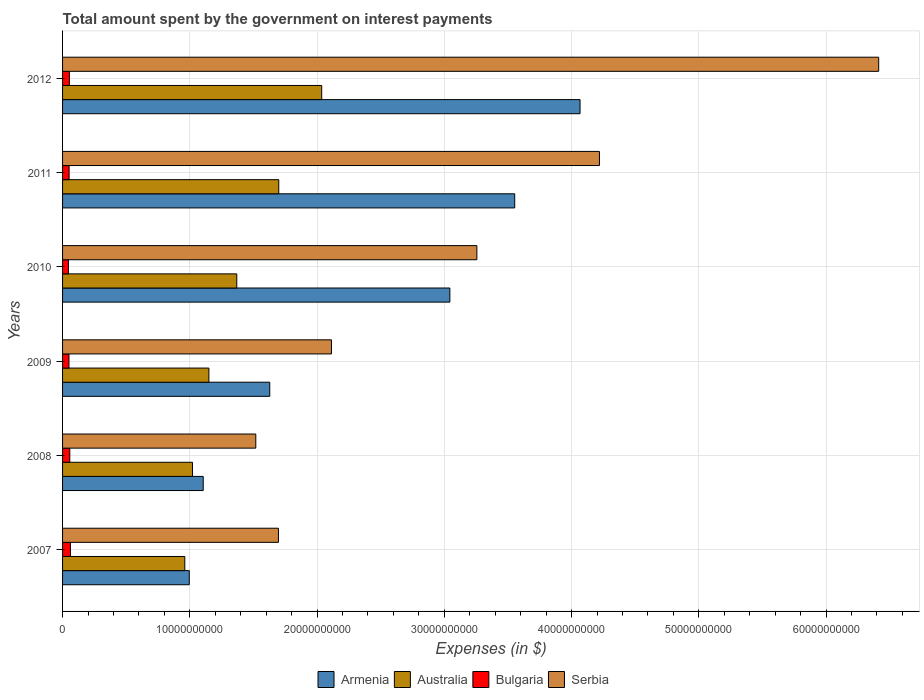How many groups of bars are there?
Keep it short and to the point. 6. Are the number of bars on each tick of the Y-axis equal?
Make the answer very short. Yes. How many bars are there on the 4th tick from the top?
Offer a very short reply. 4. How many bars are there on the 1st tick from the bottom?
Provide a short and direct response. 4. What is the label of the 6th group of bars from the top?
Give a very brief answer. 2007. In how many cases, is the number of bars for a given year not equal to the number of legend labels?
Ensure brevity in your answer.  0. What is the amount spent on interest payments by the government in Australia in 2012?
Make the answer very short. 2.04e+1. Across all years, what is the maximum amount spent on interest payments by the government in Australia?
Your response must be concise. 2.04e+1. Across all years, what is the minimum amount spent on interest payments by the government in Australia?
Ensure brevity in your answer.  9.60e+09. In which year was the amount spent on interest payments by the government in Bulgaria minimum?
Provide a short and direct response. 2010. What is the total amount spent on interest payments by the government in Serbia in the graph?
Make the answer very short. 1.92e+11. What is the difference between the amount spent on interest payments by the government in Armenia in 2007 and that in 2008?
Give a very brief answer. -1.10e+09. What is the difference between the amount spent on interest payments by the government in Bulgaria in 2011 and the amount spent on interest payments by the government in Serbia in 2008?
Keep it short and to the point. -1.47e+1. What is the average amount spent on interest payments by the government in Bulgaria per year?
Your answer should be compact. 5.33e+08. In the year 2009, what is the difference between the amount spent on interest payments by the government in Bulgaria and amount spent on interest payments by the government in Serbia?
Give a very brief answer. -2.06e+1. In how many years, is the amount spent on interest payments by the government in Armenia greater than 40000000000 $?
Your response must be concise. 1. What is the ratio of the amount spent on interest payments by the government in Bulgaria in 2007 to that in 2008?
Your response must be concise. 1.09. What is the difference between the highest and the second highest amount spent on interest payments by the government in Bulgaria?
Offer a terse response. 5.00e+07. What is the difference between the highest and the lowest amount spent on interest payments by the government in Bulgaria?
Provide a succinct answer. 1.59e+08. Is it the case that in every year, the sum of the amount spent on interest payments by the government in Serbia and amount spent on interest payments by the government in Australia is greater than the sum of amount spent on interest payments by the government in Bulgaria and amount spent on interest payments by the government in Armenia?
Give a very brief answer. No. What does the 1st bar from the bottom in 2010 represents?
Make the answer very short. Armenia. How many years are there in the graph?
Offer a very short reply. 6. Are the values on the major ticks of X-axis written in scientific E-notation?
Your answer should be very brief. No. Does the graph contain any zero values?
Provide a short and direct response. No. Where does the legend appear in the graph?
Give a very brief answer. Bottom center. What is the title of the graph?
Make the answer very short. Total amount spent by the government on interest payments. Does "Bangladesh" appear as one of the legend labels in the graph?
Provide a short and direct response. No. What is the label or title of the X-axis?
Your response must be concise. Expenses (in $). What is the label or title of the Y-axis?
Your answer should be compact. Years. What is the Expenses (in $) in Armenia in 2007?
Keep it short and to the point. 9.96e+09. What is the Expenses (in $) in Australia in 2007?
Your answer should be compact. 9.60e+09. What is the Expenses (in $) of Bulgaria in 2007?
Ensure brevity in your answer.  6.19e+08. What is the Expenses (in $) of Serbia in 2007?
Provide a succinct answer. 1.70e+1. What is the Expenses (in $) in Armenia in 2008?
Provide a short and direct response. 1.11e+1. What is the Expenses (in $) in Australia in 2008?
Your answer should be very brief. 1.02e+1. What is the Expenses (in $) of Bulgaria in 2008?
Offer a very short reply. 5.69e+08. What is the Expenses (in $) in Serbia in 2008?
Your response must be concise. 1.52e+1. What is the Expenses (in $) of Armenia in 2009?
Provide a short and direct response. 1.63e+1. What is the Expenses (in $) in Australia in 2009?
Provide a short and direct response. 1.15e+1. What is the Expenses (in $) in Bulgaria in 2009?
Provide a succinct answer. 5.03e+08. What is the Expenses (in $) of Serbia in 2009?
Your answer should be very brief. 2.11e+1. What is the Expenses (in $) of Armenia in 2010?
Provide a succinct answer. 3.04e+1. What is the Expenses (in $) of Australia in 2010?
Keep it short and to the point. 1.37e+1. What is the Expenses (in $) in Bulgaria in 2010?
Make the answer very short. 4.60e+08. What is the Expenses (in $) of Serbia in 2010?
Provide a short and direct response. 3.26e+1. What is the Expenses (in $) of Armenia in 2011?
Offer a terse response. 3.55e+1. What is the Expenses (in $) of Australia in 2011?
Your response must be concise. 1.70e+1. What is the Expenses (in $) of Bulgaria in 2011?
Offer a very short reply. 5.15e+08. What is the Expenses (in $) in Serbia in 2011?
Your answer should be compact. 4.22e+1. What is the Expenses (in $) in Armenia in 2012?
Offer a very short reply. 4.07e+1. What is the Expenses (in $) of Australia in 2012?
Give a very brief answer. 2.04e+1. What is the Expenses (in $) of Bulgaria in 2012?
Provide a succinct answer. 5.36e+08. What is the Expenses (in $) of Serbia in 2012?
Your answer should be compact. 6.41e+1. Across all years, what is the maximum Expenses (in $) in Armenia?
Provide a short and direct response. 4.07e+1. Across all years, what is the maximum Expenses (in $) of Australia?
Give a very brief answer. 2.04e+1. Across all years, what is the maximum Expenses (in $) of Bulgaria?
Keep it short and to the point. 6.19e+08. Across all years, what is the maximum Expenses (in $) of Serbia?
Keep it short and to the point. 6.41e+1. Across all years, what is the minimum Expenses (in $) in Armenia?
Offer a very short reply. 9.96e+09. Across all years, what is the minimum Expenses (in $) of Australia?
Offer a terse response. 9.60e+09. Across all years, what is the minimum Expenses (in $) of Bulgaria?
Your response must be concise. 4.60e+08. Across all years, what is the minimum Expenses (in $) in Serbia?
Your answer should be compact. 1.52e+1. What is the total Expenses (in $) of Armenia in the graph?
Offer a terse response. 1.44e+11. What is the total Expenses (in $) of Australia in the graph?
Provide a succinct answer. 8.24e+1. What is the total Expenses (in $) of Bulgaria in the graph?
Ensure brevity in your answer.  3.20e+09. What is the total Expenses (in $) of Serbia in the graph?
Provide a succinct answer. 1.92e+11. What is the difference between the Expenses (in $) of Armenia in 2007 and that in 2008?
Make the answer very short. -1.10e+09. What is the difference between the Expenses (in $) of Australia in 2007 and that in 2008?
Provide a succinct answer. -6.05e+08. What is the difference between the Expenses (in $) in Bulgaria in 2007 and that in 2008?
Your answer should be compact. 5.00e+07. What is the difference between the Expenses (in $) in Serbia in 2007 and that in 2008?
Your answer should be compact. 1.78e+09. What is the difference between the Expenses (in $) of Armenia in 2007 and that in 2009?
Make the answer very short. -6.32e+09. What is the difference between the Expenses (in $) of Australia in 2007 and that in 2009?
Offer a terse response. -1.89e+09. What is the difference between the Expenses (in $) in Bulgaria in 2007 and that in 2009?
Your answer should be very brief. 1.16e+08. What is the difference between the Expenses (in $) in Serbia in 2007 and that in 2009?
Make the answer very short. -4.17e+09. What is the difference between the Expenses (in $) of Armenia in 2007 and that in 2010?
Provide a succinct answer. -2.05e+1. What is the difference between the Expenses (in $) of Australia in 2007 and that in 2010?
Your answer should be compact. -4.09e+09. What is the difference between the Expenses (in $) of Bulgaria in 2007 and that in 2010?
Provide a succinct answer. 1.59e+08. What is the difference between the Expenses (in $) of Serbia in 2007 and that in 2010?
Give a very brief answer. -1.56e+1. What is the difference between the Expenses (in $) of Armenia in 2007 and that in 2011?
Offer a terse response. -2.56e+1. What is the difference between the Expenses (in $) of Australia in 2007 and that in 2011?
Give a very brief answer. -7.38e+09. What is the difference between the Expenses (in $) in Bulgaria in 2007 and that in 2011?
Make the answer very short. 1.04e+08. What is the difference between the Expenses (in $) of Serbia in 2007 and that in 2011?
Offer a terse response. -2.52e+1. What is the difference between the Expenses (in $) in Armenia in 2007 and that in 2012?
Your response must be concise. -3.07e+1. What is the difference between the Expenses (in $) in Australia in 2007 and that in 2012?
Offer a very short reply. -1.08e+1. What is the difference between the Expenses (in $) of Bulgaria in 2007 and that in 2012?
Your response must be concise. 8.26e+07. What is the difference between the Expenses (in $) of Serbia in 2007 and that in 2012?
Give a very brief answer. -4.72e+1. What is the difference between the Expenses (in $) of Armenia in 2008 and that in 2009?
Your answer should be very brief. -5.23e+09. What is the difference between the Expenses (in $) of Australia in 2008 and that in 2009?
Ensure brevity in your answer.  -1.29e+09. What is the difference between the Expenses (in $) in Bulgaria in 2008 and that in 2009?
Your response must be concise. 6.62e+07. What is the difference between the Expenses (in $) of Serbia in 2008 and that in 2009?
Provide a succinct answer. -5.95e+09. What is the difference between the Expenses (in $) in Armenia in 2008 and that in 2010?
Ensure brevity in your answer.  -1.94e+1. What is the difference between the Expenses (in $) of Australia in 2008 and that in 2010?
Offer a terse response. -3.48e+09. What is the difference between the Expenses (in $) of Bulgaria in 2008 and that in 2010?
Keep it short and to the point. 1.09e+08. What is the difference between the Expenses (in $) of Serbia in 2008 and that in 2010?
Ensure brevity in your answer.  -1.74e+1. What is the difference between the Expenses (in $) of Armenia in 2008 and that in 2011?
Your response must be concise. -2.45e+1. What is the difference between the Expenses (in $) of Australia in 2008 and that in 2011?
Give a very brief answer. -6.78e+09. What is the difference between the Expenses (in $) of Bulgaria in 2008 and that in 2011?
Give a very brief answer. 5.42e+07. What is the difference between the Expenses (in $) in Serbia in 2008 and that in 2011?
Your answer should be very brief. -2.70e+1. What is the difference between the Expenses (in $) of Armenia in 2008 and that in 2012?
Your answer should be compact. -2.96e+1. What is the difference between the Expenses (in $) in Australia in 2008 and that in 2012?
Offer a very short reply. -1.02e+1. What is the difference between the Expenses (in $) of Bulgaria in 2008 and that in 2012?
Provide a short and direct response. 3.26e+07. What is the difference between the Expenses (in $) in Serbia in 2008 and that in 2012?
Make the answer very short. -4.89e+1. What is the difference between the Expenses (in $) of Armenia in 2009 and that in 2010?
Provide a succinct answer. -1.42e+1. What is the difference between the Expenses (in $) in Australia in 2009 and that in 2010?
Your response must be concise. -2.19e+09. What is the difference between the Expenses (in $) in Bulgaria in 2009 and that in 2010?
Provide a succinct answer. 4.27e+07. What is the difference between the Expenses (in $) in Serbia in 2009 and that in 2010?
Make the answer very short. -1.14e+1. What is the difference between the Expenses (in $) in Armenia in 2009 and that in 2011?
Keep it short and to the point. -1.93e+1. What is the difference between the Expenses (in $) in Australia in 2009 and that in 2011?
Make the answer very short. -5.49e+09. What is the difference between the Expenses (in $) in Bulgaria in 2009 and that in 2011?
Provide a succinct answer. -1.20e+07. What is the difference between the Expenses (in $) in Serbia in 2009 and that in 2011?
Keep it short and to the point. -2.11e+1. What is the difference between the Expenses (in $) of Armenia in 2009 and that in 2012?
Provide a succinct answer. -2.44e+1. What is the difference between the Expenses (in $) of Australia in 2009 and that in 2012?
Offer a very short reply. -8.87e+09. What is the difference between the Expenses (in $) of Bulgaria in 2009 and that in 2012?
Provide a succinct answer. -3.36e+07. What is the difference between the Expenses (in $) in Serbia in 2009 and that in 2012?
Your answer should be very brief. -4.30e+1. What is the difference between the Expenses (in $) in Armenia in 2010 and that in 2011?
Provide a short and direct response. -5.10e+09. What is the difference between the Expenses (in $) of Australia in 2010 and that in 2011?
Your response must be concise. -3.30e+09. What is the difference between the Expenses (in $) of Bulgaria in 2010 and that in 2011?
Offer a terse response. -5.47e+07. What is the difference between the Expenses (in $) in Serbia in 2010 and that in 2011?
Your response must be concise. -9.63e+09. What is the difference between the Expenses (in $) of Armenia in 2010 and that in 2012?
Offer a terse response. -1.02e+1. What is the difference between the Expenses (in $) in Australia in 2010 and that in 2012?
Your answer should be compact. -6.67e+09. What is the difference between the Expenses (in $) of Bulgaria in 2010 and that in 2012?
Offer a terse response. -7.62e+07. What is the difference between the Expenses (in $) in Serbia in 2010 and that in 2012?
Provide a succinct answer. -3.16e+1. What is the difference between the Expenses (in $) of Armenia in 2011 and that in 2012?
Your answer should be compact. -5.13e+09. What is the difference between the Expenses (in $) in Australia in 2011 and that in 2012?
Your answer should be compact. -3.38e+09. What is the difference between the Expenses (in $) in Bulgaria in 2011 and that in 2012?
Keep it short and to the point. -2.16e+07. What is the difference between the Expenses (in $) of Serbia in 2011 and that in 2012?
Make the answer very short. -2.19e+1. What is the difference between the Expenses (in $) of Armenia in 2007 and the Expenses (in $) of Australia in 2008?
Keep it short and to the point. -2.53e+08. What is the difference between the Expenses (in $) in Armenia in 2007 and the Expenses (in $) in Bulgaria in 2008?
Keep it short and to the point. 9.39e+09. What is the difference between the Expenses (in $) of Armenia in 2007 and the Expenses (in $) of Serbia in 2008?
Ensure brevity in your answer.  -5.23e+09. What is the difference between the Expenses (in $) of Australia in 2007 and the Expenses (in $) of Bulgaria in 2008?
Your answer should be compact. 9.04e+09. What is the difference between the Expenses (in $) of Australia in 2007 and the Expenses (in $) of Serbia in 2008?
Offer a very short reply. -5.58e+09. What is the difference between the Expenses (in $) of Bulgaria in 2007 and the Expenses (in $) of Serbia in 2008?
Keep it short and to the point. -1.46e+1. What is the difference between the Expenses (in $) of Armenia in 2007 and the Expenses (in $) of Australia in 2009?
Your answer should be compact. -1.54e+09. What is the difference between the Expenses (in $) of Armenia in 2007 and the Expenses (in $) of Bulgaria in 2009?
Your answer should be compact. 9.45e+09. What is the difference between the Expenses (in $) in Armenia in 2007 and the Expenses (in $) in Serbia in 2009?
Keep it short and to the point. -1.12e+1. What is the difference between the Expenses (in $) of Australia in 2007 and the Expenses (in $) of Bulgaria in 2009?
Offer a very short reply. 9.10e+09. What is the difference between the Expenses (in $) in Australia in 2007 and the Expenses (in $) in Serbia in 2009?
Your answer should be compact. -1.15e+1. What is the difference between the Expenses (in $) of Bulgaria in 2007 and the Expenses (in $) of Serbia in 2009?
Offer a terse response. -2.05e+1. What is the difference between the Expenses (in $) in Armenia in 2007 and the Expenses (in $) in Australia in 2010?
Provide a short and direct response. -3.73e+09. What is the difference between the Expenses (in $) of Armenia in 2007 and the Expenses (in $) of Bulgaria in 2010?
Make the answer very short. 9.50e+09. What is the difference between the Expenses (in $) of Armenia in 2007 and the Expenses (in $) of Serbia in 2010?
Offer a very short reply. -2.26e+1. What is the difference between the Expenses (in $) in Australia in 2007 and the Expenses (in $) in Bulgaria in 2010?
Give a very brief answer. 9.15e+09. What is the difference between the Expenses (in $) in Australia in 2007 and the Expenses (in $) in Serbia in 2010?
Your answer should be very brief. -2.30e+1. What is the difference between the Expenses (in $) of Bulgaria in 2007 and the Expenses (in $) of Serbia in 2010?
Ensure brevity in your answer.  -3.19e+1. What is the difference between the Expenses (in $) in Armenia in 2007 and the Expenses (in $) in Australia in 2011?
Make the answer very short. -7.03e+09. What is the difference between the Expenses (in $) in Armenia in 2007 and the Expenses (in $) in Bulgaria in 2011?
Make the answer very short. 9.44e+09. What is the difference between the Expenses (in $) of Armenia in 2007 and the Expenses (in $) of Serbia in 2011?
Give a very brief answer. -3.22e+1. What is the difference between the Expenses (in $) in Australia in 2007 and the Expenses (in $) in Bulgaria in 2011?
Your answer should be very brief. 9.09e+09. What is the difference between the Expenses (in $) in Australia in 2007 and the Expenses (in $) in Serbia in 2011?
Make the answer very short. -3.26e+1. What is the difference between the Expenses (in $) of Bulgaria in 2007 and the Expenses (in $) of Serbia in 2011?
Your answer should be very brief. -4.16e+1. What is the difference between the Expenses (in $) of Armenia in 2007 and the Expenses (in $) of Australia in 2012?
Give a very brief answer. -1.04e+1. What is the difference between the Expenses (in $) in Armenia in 2007 and the Expenses (in $) in Bulgaria in 2012?
Offer a very short reply. 9.42e+09. What is the difference between the Expenses (in $) in Armenia in 2007 and the Expenses (in $) in Serbia in 2012?
Keep it short and to the point. -5.42e+1. What is the difference between the Expenses (in $) of Australia in 2007 and the Expenses (in $) of Bulgaria in 2012?
Keep it short and to the point. 9.07e+09. What is the difference between the Expenses (in $) of Australia in 2007 and the Expenses (in $) of Serbia in 2012?
Your response must be concise. -5.45e+1. What is the difference between the Expenses (in $) of Bulgaria in 2007 and the Expenses (in $) of Serbia in 2012?
Your response must be concise. -6.35e+1. What is the difference between the Expenses (in $) in Armenia in 2008 and the Expenses (in $) in Australia in 2009?
Your answer should be very brief. -4.45e+08. What is the difference between the Expenses (in $) of Armenia in 2008 and the Expenses (in $) of Bulgaria in 2009?
Keep it short and to the point. 1.06e+1. What is the difference between the Expenses (in $) of Armenia in 2008 and the Expenses (in $) of Serbia in 2009?
Offer a terse response. -1.01e+1. What is the difference between the Expenses (in $) of Australia in 2008 and the Expenses (in $) of Bulgaria in 2009?
Keep it short and to the point. 9.71e+09. What is the difference between the Expenses (in $) of Australia in 2008 and the Expenses (in $) of Serbia in 2009?
Your answer should be compact. -1.09e+1. What is the difference between the Expenses (in $) of Bulgaria in 2008 and the Expenses (in $) of Serbia in 2009?
Offer a very short reply. -2.06e+1. What is the difference between the Expenses (in $) in Armenia in 2008 and the Expenses (in $) in Australia in 2010?
Offer a terse response. -2.64e+09. What is the difference between the Expenses (in $) of Armenia in 2008 and the Expenses (in $) of Bulgaria in 2010?
Your answer should be very brief. 1.06e+1. What is the difference between the Expenses (in $) of Armenia in 2008 and the Expenses (in $) of Serbia in 2010?
Your response must be concise. -2.15e+1. What is the difference between the Expenses (in $) of Australia in 2008 and the Expenses (in $) of Bulgaria in 2010?
Give a very brief answer. 9.75e+09. What is the difference between the Expenses (in $) of Australia in 2008 and the Expenses (in $) of Serbia in 2010?
Keep it short and to the point. -2.23e+1. What is the difference between the Expenses (in $) in Bulgaria in 2008 and the Expenses (in $) in Serbia in 2010?
Provide a succinct answer. -3.20e+1. What is the difference between the Expenses (in $) of Armenia in 2008 and the Expenses (in $) of Australia in 2011?
Your answer should be very brief. -5.94e+09. What is the difference between the Expenses (in $) in Armenia in 2008 and the Expenses (in $) in Bulgaria in 2011?
Ensure brevity in your answer.  1.05e+1. What is the difference between the Expenses (in $) in Armenia in 2008 and the Expenses (in $) in Serbia in 2011?
Your answer should be compact. -3.11e+1. What is the difference between the Expenses (in $) in Australia in 2008 and the Expenses (in $) in Bulgaria in 2011?
Your answer should be compact. 9.70e+09. What is the difference between the Expenses (in $) in Australia in 2008 and the Expenses (in $) in Serbia in 2011?
Ensure brevity in your answer.  -3.20e+1. What is the difference between the Expenses (in $) in Bulgaria in 2008 and the Expenses (in $) in Serbia in 2011?
Offer a terse response. -4.16e+1. What is the difference between the Expenses (in $) of Armenia in 2008 and the Expenses (in $) of Australia in 2012?
Ensure brevity in your answer.  -9.31e+09. What is the difference between the Expenses (in $) of Armenia in 2008 and the Expenses (in $) of Bulgaria in 2012?
Your answer should be very brief. 1.05e+1. What is the difference between the Expenses (in $) in Armenia in 2008 and the Expenses (in $) in Serbia in 2012?
Keep it short and to the point. -5.31e+1. What is the difference between the Expenses (in $) in Australia in 2008 and the Expenses (in $) in Bulgaria in 2012?
Provide a succinct answer. 9.67e+09. What is the difference between the Expenses (in $) in Australia in 2008 and the Expenses (in $) in Serbia in 2012?
Offer a very short reply. -5.39e+1. What is the difference between the Expenses (in $) of Bulgaria in 2008 and the Expenses (in $) of Serbia in 2012?
Make the answer very short. -6.36e+1. What is the difference between the Expenses (in $) in Armenia in 2009 and the Expenses (in $) in Australia in 2010?
Provide a short and direct response. 2.59e+09. What is the difference between the Expenses (in $) in Armenia in 2009 and the Expenses (in $) in Bulgaria in 2010?
Give a very brief answer. 1.58e+1. What is the difference between the Expenses (in $) in Armenia in 2009 and the Expenses (in $) in Serbia in 2010?
Provide a succinct answer. -1.63e+1. What is the difference between the Expenses (in $) in Australia in 2009 and the Expenses (in $) in Bulgaria in 2010?
Make the answer very short. 1.10e+1. What is the difference between the Expenses (in $) of Australia in 2009 and the Expenses (in $) of Serbia in 2010?
Your answer should be very brief. -2.11e+1. What is the difference between the Expenses (in $) of Bulgaria in 2009 and the Expenses (in $) of Serbia in 2010?
Ensure brevity in your answer.  -3.21e+1. What is the difference between the Expenses (in $) in Armenia in 2009 and the Expenses (in $) in Australia in 2011?
Offer a terse response. -7.08e+08. What is the difference between the Expenses (in $) of Armenia in 2009 and the Expenses (in $) of Bulgaria in 2011?
Provide a succinct answer. 1.58e+1. What is the difference between the Expenses (in $) of Armenia in 2009 and the Expenses (in $) of Serbia in 2011?
Keep it short and to the point. -2.59e+1. What is the difference between the Expenses (in $) in Australia in 2009 and the Expenses (in $) in Bulgaria in 2011?
Your answer should be compact. 1.10e+1. What is the difference between the Expenses (in $) of Australia in 2009 and the Expenses (in $) of Serbia in 2011?
Ensure brevity in your answer.  -3.07e+1. What is the difference between the Expenses (in $) in Bulgaria in 2009 and the Expenses (in $) in Serbia in 2011?
Your answer should be very brief. -4.17e+1. What is the difference between the Expenses (in $) of Armenia in 2009 and the Expenses (in $) of Australia in 2012?
Make the answer very short. -4.08e+09. What is the difference between the Expenses (in $) in Armenia in 2009 and the Expenses (in $) in Bulgaria in 2012?
Give a very brief answer. 1.57e+1. What is the difference between the Expenses (in $) in Armenia in 2009 and the Expenses (in $) in Serbia in 2012?
Keep it short and to the point. -4.79e+1. What is the difference between the Expenses (in $) in Australia in 2009 and the Expenses (in $) in Bulgaria in 2012?
Offer a terse response. 1.10e+1. What is the difference between the Expenses (in $) of Australia in 2009 and the Expenses (in $) of Serbia in 2012?
Ensure brevity in your answer.  -5.26e+1. What is the difference between the Expenses (in $) in Bulgaria in 2009 and the Expenses (in $) in Serbia in 2012?
Provide a succinct answer. -6.36e+1. What is the difference between the Expenses (in $) of Armenia in 2010 and the Expenses (in $) of Australia in 2011?
Make the answer very short. 1.34e+1. What is the difference between the Expenses (in $) in Armenia in 2010 and the Expenses (in $) in Bulgaria in 2011?
Your answer should be compact. 2.99e+1. What is the difference between the Expenses (in $) in Armenia in 2010 and the Expenses (in $) in Serbia in 2011?
Offer a very short reply. -1.18e+1. What is the difference between the Expenses (in $) in Australia in 2010 and the Expenses (in $) in Bulgaria in 2011?
Offer a very short reply. 1.32e+1. What is the difference between the Expenses (in $) in Australia in 2010 and the Expenses (in $) in Serbia in 2011?
Your answer should be compact. -2.85e+1. What is the difference between the Expenses (in $) in Bulgaria in 2010 and the Expenses (in $) in Serbia in 2011?
Keep it short and to the point. -4.17e+1. What is the difference between the Expenses (in $) in Armenia in 2010 and the Expenses (in $) in Australia in 2012?
Your answer should be very brief. 1.01e+1. What is the difference between the Expenses (in $) of Armenia in 2010 and the Expenses (in $) of Bulgaria in 2012?
Provide a succinct answer. 2.99e+1. What is the difference between the Expenses (in $) in Armenia in 2010 and the Expenses (in $) in Serbia in 2012?
Your answer should be very brief. -3.37e+1. What is the difference between the Expenses (in $) in Australia in 2010 and the Expenses (in $) in Bulgaria in 2012?
Give a very brief answer. 1.32e+1. What is the difference between the Expenses (in $) of Australia in 2010 and the Expenses (in $) of Serbia in 2012?
Give a very brief answer. -5.04e+1. What is the difference between the Expenses (in $) of Bulgaria in 2010 and the Expenses (in $) of Serbia in 2012?
Offer a very short reply. -6.37e+1. What is the difference between the Expenses (in $) in Armenia in 2011 and the Expenses (in $) in Australia in 2012?
Provide a succinct answer. 1.52e+1. What is the difference between the Expenses (in $) in Armenia in 2011 and the Expenses (in $) in Bulgaria in 2012?
Provide a succinct answer. 3.50e+1. What is the difference between the Expenses (in $) of Armenia in 2011 and the Expenses (in $) of Serbia in 2012?
Your answer should be compact. -2.86e+1. What is the difference between the Expenses (in $) in Australia in 2011 and the Expenses (in $) in Bulgaria in 2012?
Your response must be concise. 1.65e+1. What is the difference between the Expenses (in $) in Australia in 2011 and the Expenses (in $) in Serbia in 2012?
Ensure brevity in your answer.  -4.71e+1. What is the difference between the Expenses (in $) in Bulgaria in 2011 and the Expenses (in $) in Serbia in 2012?
Your response must be concise. -6.36e+1. What is the average Expenses (in $) in Armenia per year?
Your answer should be compact. 2.40e+1. What is the average Expenses (in $) in Australia per year?
Offer a terse response. 1.37e+1. What is the average Expenses (in $) in Bulgaria per year?
Make the answer very short. 5.33e+08. What is the average Expenses (in $) in Serbia per year?
Make the answer very short. 3.20e+1. In the year 2007, what is the difference between the Expenses (in $) of Armenia and Expenses (in $) of Australia?
Make the answer very short. 3.52e+08. In the year 2007, what is the difference between the Expenses (in $) in Armenia and Expenses (in $) in Bulgaria?
Your answer should be very brief. 9.34e+09. In the year 2007, what is the difference between the Expenses (in $) of Armenia and Expenses (in $) of Serbia?
Keep it short and to the point. -7.01e+09. In the year 2007, what is the difference between the Expenses (in $) in Australia and Expenses (in $) in Bulgaria?
Your answer should be very brief. 8.99e+09. In the year 2007, what is the difference between the Expenses (in $) of Australia and Expenses (in $) of Serbia?
Your response must be concise. -7.36e+09. In the year 2007, what is the difference between the Expenses (in $) in Bulgaria and Expenses (in $) in Serbia?
Give a very brief answer. -1.63e+1. In the year 2008, what is the difference between the Expenses (in $) in Armenia and Expenses (in $) in Australia?
Keep it short and to the point. 8.44e+08. In the year 2008, what is the difference between the Expenses (in $) of Armenia and Expenses (in $) of Bulgaria?
Provide a succinct answer. 1.05e+1. In the year 2008, what is the difference between the Expenses (in $) of Armenia and Expenses (in $) of Serbia?
Your response must be concise. -4.13e+09. In the year 2008, what is the difference between the Expenses (in $) in Australia and Expenses (in $) in Bulgaria?
Provide a short and direct response. 9.64e+09. In the year 2008, what is the difference between the Expenses (in $) in Australia and Expenses (in $) in Serbia?
Provide a succinct answer. -4.98e+09. In the year 2008, what is the difference between the Expenses (in $) in Bulgaria and Expenses (in $) in Serbia?
Provide a succinct answer. -1.46e+1. In the year 2009, what is the difference between the Expenses (in $) in Armenia and Expenses (in $) in Australia?
Keep it short and to the point. 4.78e+09. In the year 2009, what is the difference between the Expenses (in $) in Armenia and Expenses (in $) in Bulgaria?
Your answer should be very brief. 1.58e+1. In the year 2009, what is the difference between the Expenses (in $) in Armenia and Expenses (in $) in Serbia?
Offer a terse response. -4.85e+09. In the year 2009, what is the difference between the Expenses (in $) in Australia and Expenses (in $) in Bulgaria?
Your answer should be very brief. 1.10e+1. In the year 2009, what is the difference between the Expenses (in $) of Australia and Expenses (in $) of Serbia?
Keep it short and to the point. -9.63e+09. In the year 2009, what is the difference between the Expenses (in $) of Bulgaria and Expenses (in $) of Serbia?
Offer a terse response. -2.06e+1. In the year 2010, what is the difference between the Expenses (in $) of Armenia and Expenses (in $) of Australia?
Your answer should be very brief. 1.67e+1. In the year 2010, what is the difference between the Expenses (in $) of Armenia and Expenses (in $) of Bulgaria?
Provide a short and direct response. 3.00e+1. In the year 2010, what is the difference between the Expenses (in $) in Armenia and Expenses (in $) in Serbia?
Ensure brevity in your answer.  -2.12e+09. In the year 2010, what is the difference between the Expenses (in $) in Australia and Expenses (in $) in Bulgaria?
Your answer should be compact. 1.32e+1. In the year 2010, what is the difference between the Expenses (in $) of Australia and Expenses (in $) of Serbia?
Keep it short and to the point. -1.89e+1. In the year 2010, what is the difference between the Expenses (in $) in Bulgaria and Expenses (in $) in Serbia?
Your answer should be compact. -3.21e+1. In the year 2011, what is the difference between the Expenses (in $) in Armenia and Expenses (in $) in Australia?
Give a very brief answer. 1.85e+1. In the year 2011, what is the difference between the Expenses (in $) of Armenia and Expenses (in $) of Bulgaria?
Your answer should be compact. 3.50e+1. In the year 2011, what is the difference between the Expenses (in $) in Armenia and Expenses (in $) in Serbia?
Your answer should be very brief. -6.66e+09. In the year 2011, what is the difference between the Expenses (in $) in Australia and Expenses (in $) in Bulgaria?
Provide a succinct answer. 1.65e+1. In the year 2011, what is the difference between the Expenses (in $) in Australia and Expenses (in $) in Serbia?
Make the answer very short. -2.52e+1. In the year 2011, what is the difference between the Expenses (in $) in Bulgaria and Expenses (in $) in Serbia?
Keep it short and to the point. -4.17e+1. In the year 2012, what is the difference between the Expenses (in $) of Armenia and Expenses (in $) of Australia?
Offer a terse response. 2.03e+1. In the year 2012, what is the difference between the Expenses (in $) of Armenia and Expenses (in $) of Bulgaria?
Keep it short and to the point. 4.01e+1. In the year 2012, what is the difference between the Expenses (in $) of Armenia and Expenses (in $) of Serbia?
Offer a very short reply. -2.35e+1. In the year 2012, what is the difference between the Expenses (in $) in Australia and Expenses (in $) in Bulgaria?
Ensure brevity in your answer.  1.98e+1. In the year 2012, what is the difference between the Expenses (in $) in Australia and Expenses (in $) in Serbia?
Ensure brevity in your answer.  -4.38e+1. In the year 2012, what is the difference between the Expenses (in $) of Bulgaria and Expenses (in $) of Serbia?
Ensure brevity in your answer.  -6.36e+1. What is the ratio of the Expenses (in $) of Armenia in 2007 to that in 2008?
Make the answer very short. 0.9. What is the ratio of the Expenses (in $) of Australia in 2007 to that in 2008?
Your response must be concise. 0.94. What is the ratio of the Expenses (in $) of Bulgaria in 2007 to that in 2008?
Your response must be concise. 1.09. What is the ratio of the Expenses (in $) in Serbia in 2007 to that in 2008?
Provide a short and direct response. 1.12. What is the ratio of the Expenses (in $) of Armenia in 2007 to that in 2009?
Your answer should be compact. 0.61. What is the ratio of the Expenses (in $) in Australia in 2007 to that in 2009?
Ensure brevity in your answer.  0.84. What is the ratio of the Expenses (in $) in Bulgaria in 2007 to that in 2009?
Ensure brevity in your answer.  1.23. What is the ratio of the Expenses (in $) of Serbia in 2007 to that in 2009?
Your answer should be compact. 0.8. What is the ratio of the Expenses (in $) in Armenia in 2007 to that in 2010?
Your answer should be very brief. 0.33. What is the ratio of the Expenses (in $) in Australia in 2007 to that in 2010?
Ensure brevity in your answer.  0.7. What is the ratio of the Expenses (in $) of Bulgaria in 2007 to that in 2010?
Offer a terse response. 1.35. What is the ratio of the Expenses (in $) in Serbia in 2007 to that in 2010?
Your response must be concise. 0.52. What is the ratio of the Expenses (in $) in Armenia in 2007 to that in 2011?
Offer a very short reply. 0.28. What is the ratio of the Expenses (in $) of Australia in 2007 to that in 2011?
Keep it short and to the point. 0.57. What is the ratio of the Expenses (in $) in Bulgaria in 2007 to that in 2011?
Keep it short and to the point. 1.2. What is the ratio of the Expenses (in $) in Serbia in 2007 to that in 2011?
Make the answer very short. 0.4. What is the ratio of the Expenses (in $) of Armenia in 2007 to that in 2012?
Provide a succinct answer. 0.24. What is the ratio of the Expenses (in $) in Australia in 2007 to that in 2012?
Make the answer very short. 0.47. What is the ratio of the Expenses (in $) of Bulgaria in 2007 to that in 2012?
Provide a succinct answer. 1.15. What is the ratio of the Expenses (in $) in Serbia in 2007 to that in 2012?
Offer a terse response. 0.26. What is the ratio of the Expenses (in $) in Armenia in 2008 to that in 2009?
Ensure brevity in your answer.  0.68. What is the ratio of the Expenses (in $) in Australia in 2008 to that in 2009?
Offer a terse response. 0.89. What is the ratio of the Expenses (in $) in Bulgaria in 2008 to that in 2009?
Provide a succinct answer. 1.13. What is the ratio of the Expenses (in $) of Serbia in 2008 to that in 2009?
Give a very brief answer. 0.72. What is the ratio of the Expenses (in $) of Armenia in 2008 to that in 2010?
Offer a terse response. 0.36. What is the ratio of the Expenses (in $) of Australia in 2008 to that in 2010?
Your response must be concise. 0.75. What is the ratio of the Expenses (in $) of Bulgaria in 2008 to that in 2010?
Provide a succinct answer. 1.24. What is the ratio of the Expenses (in $) in Serbia in 2008 to that in 2010?
Your answer should be compact. 0.47. What is the ratio of the Expenses (in $) of Armenia in 2008 to that in 2011?
Provide a short and direct response. 0.31. What is the ratio of the Expenses (in $) of Australia in 2008 to that in 2011?
Your answer should be very brief. 0.6. What is the ratio of the Expenses (in $) of Bulgaria in 2008 to that in 2011?
Provide a succinct answer. 1.11. What is the ratio of the Expenses (in $) in Serbia in 2008 to that in 2011?
Ensure brevity in your answer.  0.36. What is the ratio of the Expenses (in $) in Armenia in 2008 to that in 2012?
Make the answer very short. 0.27. What is the ratio of the Expenses (in $) of Australia in 2008 to that in 2012?
Your answer should be very brief. 0.5. What is the ratio of the Expenses (in $) of Bulgaria in 2008 to that in 2012?
Provide a short and direct response. 1.06. What is the ratio of the Expenses (in $) of Serbia in 2008 to that in 2012?
Your answer should be compact. 0.24. What is the ratio of the Expenses (in $) of Armenia in 2009 to that in 2010?
Give a very brief answer. 0.53. What is the ratio of the Expenses (in $) of Australia in 2009 to that in 2010?
Make the answer very short. 0.84. What is the ratio of the Expenses (in $) in Bulgaria in 2009 to that in 2010?
Ensure brevity in your answer.  1.09. What is the ratio of the Expenses (in $) of Serbia in 2009 to that in 2010?
Keep it short and to the point. 0.65. What is the ratio of the Expenses (in $) in Armenia in 2009 to that in 2011?
Offer a very short reply. 0.46. What is the ratio of the Expenses (in $) of Australia in 2009 to that in 2011?
Your answer should be very brief. 0.68. What is the ratio of the Expenses (in $) in Bulgaria in 2009 to that in 2011?
Provide a short and direct response. 0.98. What is the ratio of the Expenses (in $) in Serbia in 2009 to that in 2011?
Offer a terse response. 0.5. What is the ratio of the Expenses (in $) in Armenia in 2009 to that in 2012?
Your response must be concise. 0.4. What is the ratio of the Expenses (in $) in Australia in 2009 to that in 2012?
Your response must be concise. 0.56. What is the ratio of the Expenses (in $) of Bulgaria in 2009 to that in 2012?
Provide a short and direct response. 0.94. What is the ratio of the Expenses (in $) of Serbia in 2009 to that in 2012?
Make the answer very short. 0.33. What is the ratio of the Expenses (in $) of Armenia in 2010 to that in 2011?
Your response must be concise. 0.86. What is the ratio of the Expenses (in $) of Australia in 2010 to that in 2011?
Your answer should be compact. 0.81. What is the ratio of the Expenses (in $) in Bulgaria in 2010 to that in 2011?
Keep it short and to the point. 0.89. What is the ratio of the Expenses (in $) of Serbia in 2010 to that in 2011?
Give a very brief answer. 0.77. What is the ratio of the Expenses (in $) of Armenia in 2010 to that in 2012?
Your response must be concise. 0.75. What is the ratio of the Expenses (in $) in Australia in 2010 to that in 2012?
Offer a very short reply. 0.67. What is the ratio of the Expenses (in $) in Bulgaria in 2010 to that in 2012?
Ensure brevity in your answer.  0.86. What is the ratio of the Expenses (in $) in Serbia in 2010 to that in 2012?
Offer a very short reply. 0.51. What is the ratio of the Expenses (in $) of Armenia in 2011 to that in 2012?
Your answer should be compact. 0.87. What is the ratio of the Expenses (in $) of Australia in 2011 to that in 2012?
Keep it short and to the point. 0.83. What is the ratio of the Expenses (in $) in Bulgaria in 2011 to that in 2012?
Your response must be concise. 0.96. What is the ratio of the Expenses (in $) of Serbia in 2011 to that in 2012?
Your answer should be compact. 0.66. What is the difference between the highest and the second highest Expenses (in $) of Armenia?
Your answer should be very brief. 5.13e+09. What is the difference between the highest and the second highest Expenses (in $) in Australia?
Offer a terse response. 3.38e+09. What is the difference between the highest and the second highest Expenses (in $) in Bulgaria?
Your answer should be very brief. 5.00e+07. What is the difference between the highest and the second highest Expenses (in $) of Serbia?
Your answer should be very brief. 2.19e+1. What is the difference between the highest and the lowest Expenses (in $) of Armenia?
Offer a very short reply. 3.07e+1. What is the difference between the highest and the lowest Expenses (in $) of Australia?
Offer a very short reply. 1.08e+1. What is the difference between the highest and the lowest Expenses (in $) of Bulgaria?
Your answer should be very brief. 1.59e+08. What is the difference between the highest and the lowest Expenses (in $) in Serbia?
Offer a very short reply. 4.89e+1. 